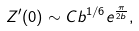Convert formula to latex. <formula><loc_0><loc_0><loc_500><loc_500>Z ^ { \prime } ( 0 ) \sim C b ^ { 1 / 6 } e ^ { \frac { \pi } { 2 b } } ,</formula> 